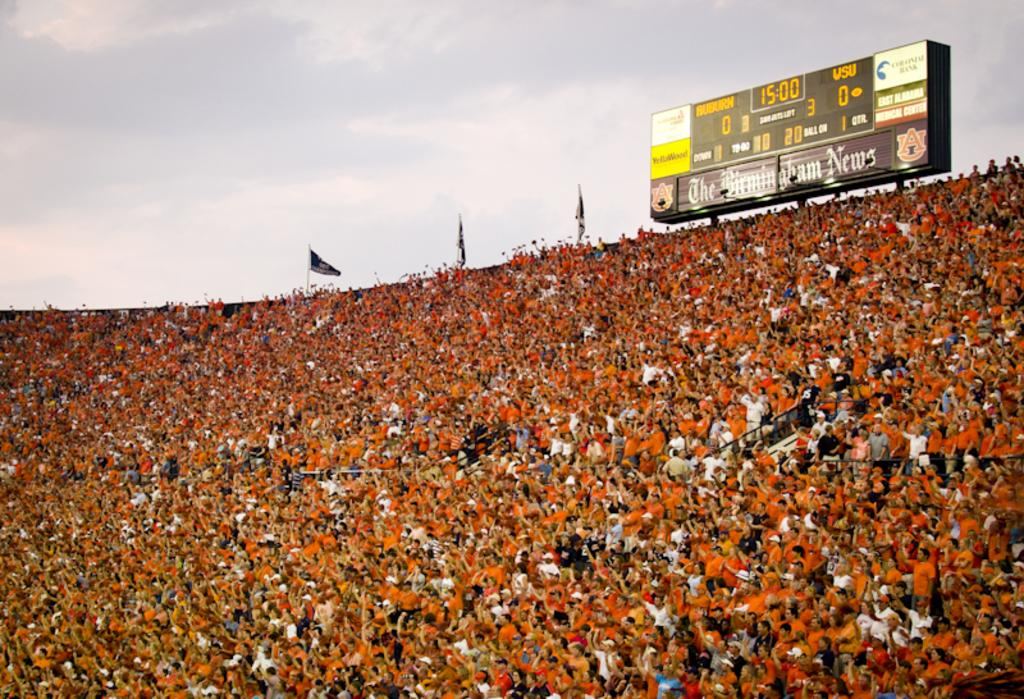<image>
Present a compact description of the photo's key features. a sign that has the time of 15:00 on it 